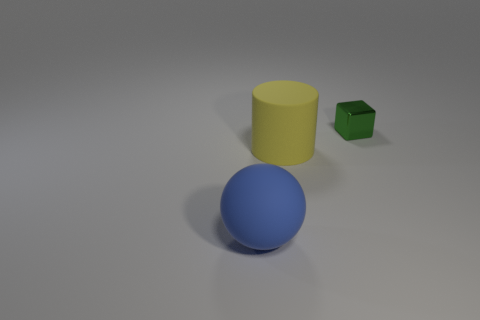Is there anything else that has the same material as the small green thing?
Make the answer very short. No. Are there any large balls that have the same material as the cube?
Your answer should be very brief. No. The large object that is to the right of the large thing on the left side of the big rubber thing behind the big blue rubber sphere is what color?
Your answer should be compact. Yellow. How many yellow things are large things or tiny matte cylinders?
Make the answer very short. 1. What is the shape of the rubber thing that is the same size as the blue sphere?
Ensure brevity in your answer.  Cylinder. There is a small green shiny block; are there any blue matte objects left of it?
Your response must be concise. Yes. There is a tiny cube that is to the right of the cylinder; is there a cylinder that is left of it?
Provide a short and direct response. Yes. Is the number of matte cylinders behind the small block less than the number of tiny cubes that are behind the yellow rubber cylinder?
Offer a very short reply. Yes. Is there anything else that has the same size as the metallic cube?
Ensure brevity in your answer.  No. What is the shape of the big blue thing?
Offer a terse response. Sphere. 